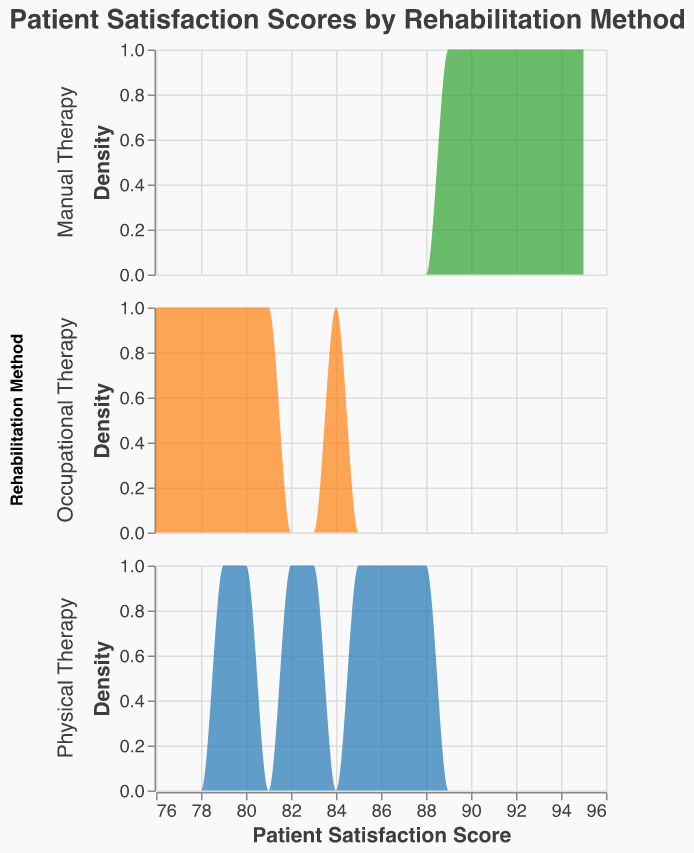What's the title of the figure? The title is usually located at the top of the figure and is clearly labeled. Here, it is mentioned specifically in the code as "Patient Satisfaction Scores by Rehabilitation Method".
Answer: Patient Satisfaction Scores by Rehabilitation Method What are the rehabilitation methods shown in the figure? The figure shows a subset of methods under the "Rehabilitation Method" facet. The three methods are "Physical Therapy", "Occupational Therapy", and "Manual Therapy".
Answer: Physical Therapy, Occupational Therapy, Manual Therapy What color is used to represent "Manual Therapy"? The code defines the colors used for each rehabilitation method. According to the color scale, "Manual Therapy" is represented by green.
Answer: Green Which rehabilitation method has the highest density peak? By observing the peaks of the density plot for each rehabilitation method, we can identify which method has the highest point on the y-axis. "Manual Therapy" has the highest density peak compared to the others.
Answer: Manual Therapy Between which score range do most "Occupational Therapy" satisfaction scores fall? By observing the density plot for "Occupational Therapy", the highest and most frequent scores can be found. Most scores fall within the 76 to 84 range where the density is higher.
Answer: 76 to 84 Which rehabilitation method shows the most variability in patient satisfaction scores? Variability can be inferred from the width of the distribution; wider plots indicate greater spread. "Physical Therapy" shows a broader range of scores, indicating higher variability.
Answer: Physical Therapy Compare the highest patient satisfaction score among the three rehabilitation methods. Observing the rightmost end of each density plot, "Manual Therapy" scores reach up to 95, which is higher than the maximum scores of "Physical Therapy" and "Occupational Therapy".
Answer: Manual Therapy What is the most common satisfaction score for "Physical Therapy"? By checking where the peak of the density plot for "Physical Therapy" is located on the x-axis, we find the most common score. The peak occurs around 83-88.
Answer: 83-88 Which method has the least common patient satisfaction score below 80? By reviewing the density plots and their y-values under the score of 80, "Manual Therapy" shows the least commonality with very low density in this range.
Answer: Manual Therapy 